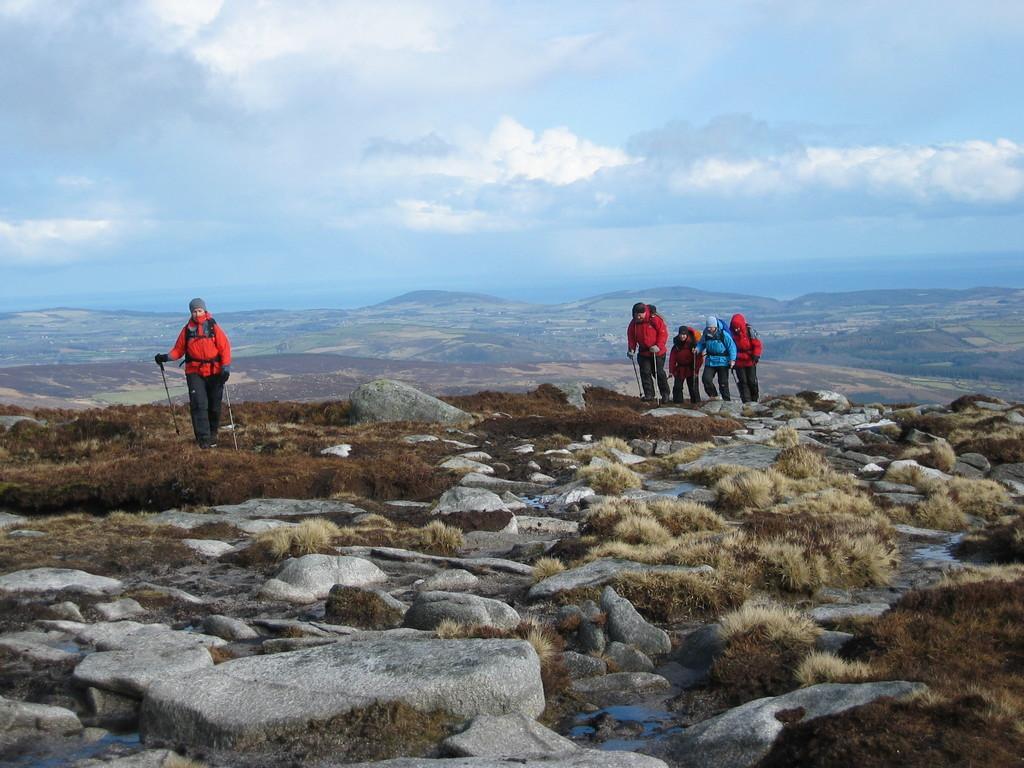How would you summarize this image in a sentence or two? On the left there is a person standing on the ground and holding sticks in their hands. On the right there are four people walking on the ground and holding two sticks in their hands and here we can see stones,water and grass. In the background there are mountains and clouds in the sky. 